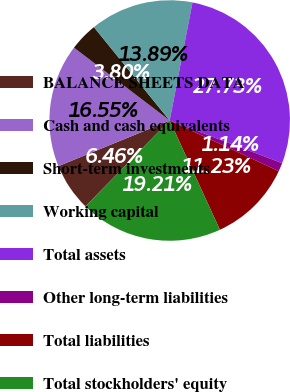Convert chart. <chart><loc_0><loc_0><loc_500><loc_500><pie_chart><fcel>BALANCE SHEETS DATA<fcel>Cash and cash equivalents<fcel>Short-term investments<fcel>Working capital<fcel>Total assets<fcel>Other long-term liabilities<fcel>Total liabilities<fcel>Total stockholders' equity<nl><fcel>6.46%<fcel>16.55%<fcel>3.8%<fcel>13.89%<fcel>27.74%<fcel>1.14%<fcel>11.23%<fcel>19.21%<nl></chart> 